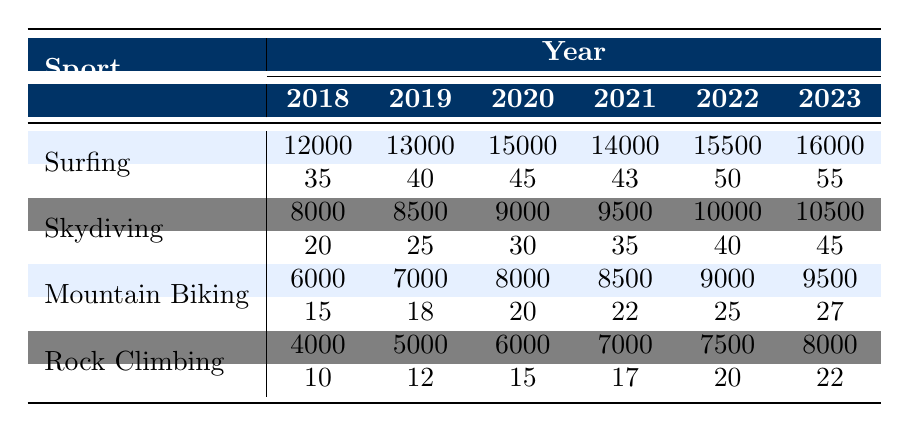What sport had the highest number of participants in 2023? In 2023, Surfing had 16,000 participants, which is more than Skydiving (10,500), Mountain Biking (9,500), and Rock Climbing (8,000).
Answer: Surfing How many events were held for Skydiving in 2021? The table shows that there were 35 events held for Skydiving in 2021.
Answer: 35 What is the total number of participants across all sports in 2022? In 2022, the participants in each sport were Surfing (15,500), Skydiving (10,000), Mountain Biking (9,000), and Rock Climbing (7,500). Summing these gives 15,500 + 10,000 + 9,000 + 7,500 = 42,000.
Answer: 42000 Did the number of participants in Rock Climbing increase every year from 2018 to 2023? The number of participants in Rock Climbing increased each year, starting from 4,000 in 2018 and reaching 8,000 in 2023, confirming consistent growth.
Answer: Yes What was the average number of participants for Mountain Biking from 2018 to 2023? The participants for Mountain Biking were 6,000 (2018), 7,000 (2019), 8,000 (2020), 8,500 (2021), 9,000 (2022), and 9,500 (2023). Adding these gives 48,000, and dividing by 6 (the number of years) results in an average of 8,000.
Answer: 8000 Which sport had the least number of participants in 2019? In 2019, Rock Climbing had the least participants at 5,000, compared to Surfing (13,000), Skydiving (8,500), and Mountain Biking (7,000).
Answer: Rock Climbing What is the percentage increase in participants for Surfing from 2018 to 2023? To find the percentage increase, first calculate the difference in participants: 16,000 (2023) - 12,000 (2018) = 4,000. Then, divide by the original number (12,000) and multiply by 100: (4,000 / 12,000) * 100 = 33.33%.
Answer: 33.33% Did Mountain Biking have more participants than Rock Climbing in every year from 2018 to 2023? Comparing the participants in each year, Mountain Biking had 6,000 vs. Rock Climbing's 4,000 in 2018, 7,000 vs. 5,000 in 2019, 8,000 vs. 6,000 in 2020, 8,500 vs. 7,000 in 2021, 9,000 vs. 7,500 in 2022, and 9,500 vs. 8,000 in 2023. Therefore, Mountain Biking did have more participants every year.
Answer: Yes What was the total number of events for Surfing from 2018 to 2023? The number of events for Surfing from 2018 to 2023 were: 35 (2018), 40 (2019), 45 (2020), 43 (2021), 50 (2022), and 55 (2023). Adding these gives: 35 + 40 + 45 + 43 + 50 + 55 = 268.
Answer: 268 What sport had the highest growth in the number of participants from the previous year in 2020? To determine the highest growth for 2020, observe the change in participants: Surfing increased from 13,000 (2019) to 15,000 (2020), a growth of 2,000; Skydiving from 8,500 to 9,000 (+500); Mountain Biking from 7,000 to 8,000 (+1,000); and Rock Climbing from 5,000 to 6,000 (+1,000). Surfing had the highest growth.
Answer: Surfing 